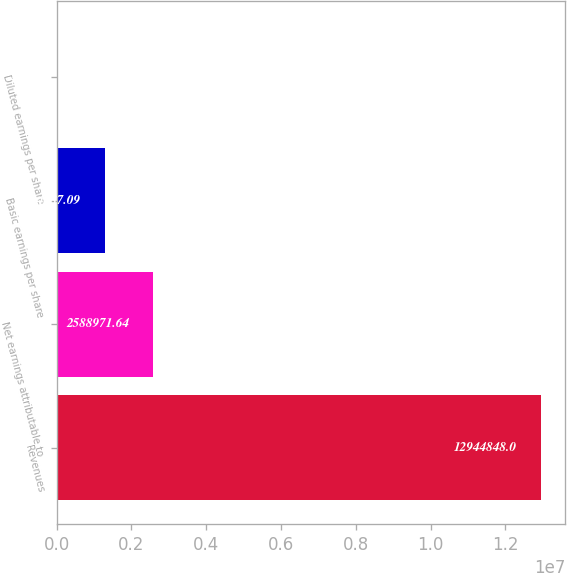Convert chart. <chart><loc_0><loc_0><loc_500><loc_500><bar_chart><fcel>Revenues<fcel>Net earnings attributable to<fcel>Basic earnings per share<fcel>Diluted earnings per share<nl><fcel>1.29448e+07<fcel>2.58897e+06<fcel>1.29449e+06<fcel>2.54<nl></chart> 